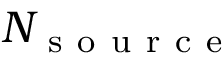<formula> <loc_0><loc_0><loc_500><loc_500>N _ { s o u r c e }</formula> 